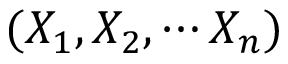<formula> <loc_0><loc_0><loc_500><loc_500>( X _ { 1 } , X _ { 2 } , \cdots X _ { n } )</formula> 